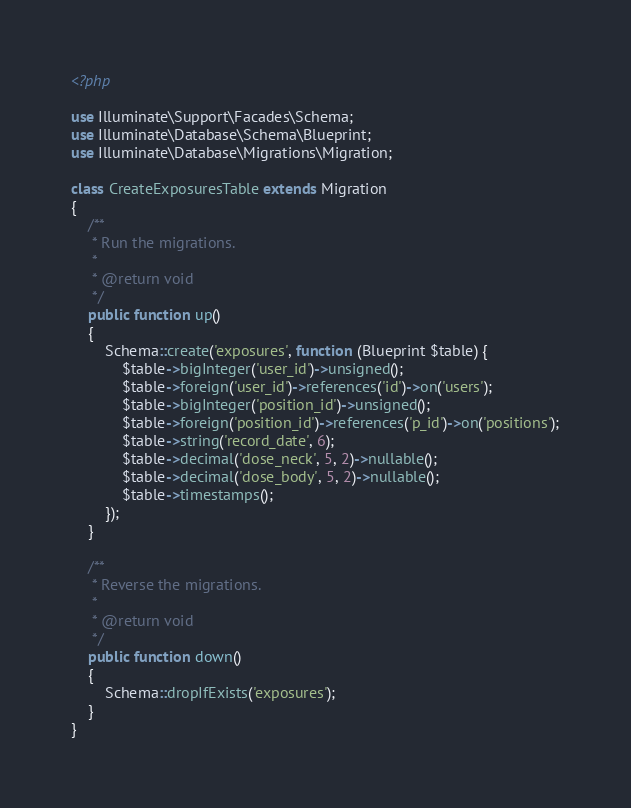Convert code to text. <code><loc_0><loc_0><loc_500><loc_500><_PHP_><?php

use Illuminate\Support\Facades\Schema;
use Illuminate\Database\Schema\Blueprint;
use Illuminate\Database\Migrations\Migration;

class CreateExposuresTable extends Migration
{
    /**
     * Run the migrations.
     *
     * @return void
     */
    public function up()
    {
        Schema::create('exposures', function (Blueprint $table) {
            $table->bigInteger('user_id')->unsigned();
            $table->foreign('user_id')->references('id')->on('users');
            $table->bigInteger('position_id')->unsigned();
            $table->foreign('position_id')->references('p_id')->on('positions');
            $table->string('record_date', 6);
            $table->decimal('dose_neck', 5, 2)->nullable();
            $table->decimal('dose_body', 5, 2)->nullable();
            $table->timestamps();
        });
    }

    /**
     * Reverse the migrations.
     *
     * @return void
     */
    public function down()
    {
        Schema::dropIfExists('exposures');
    }
}
</code> 